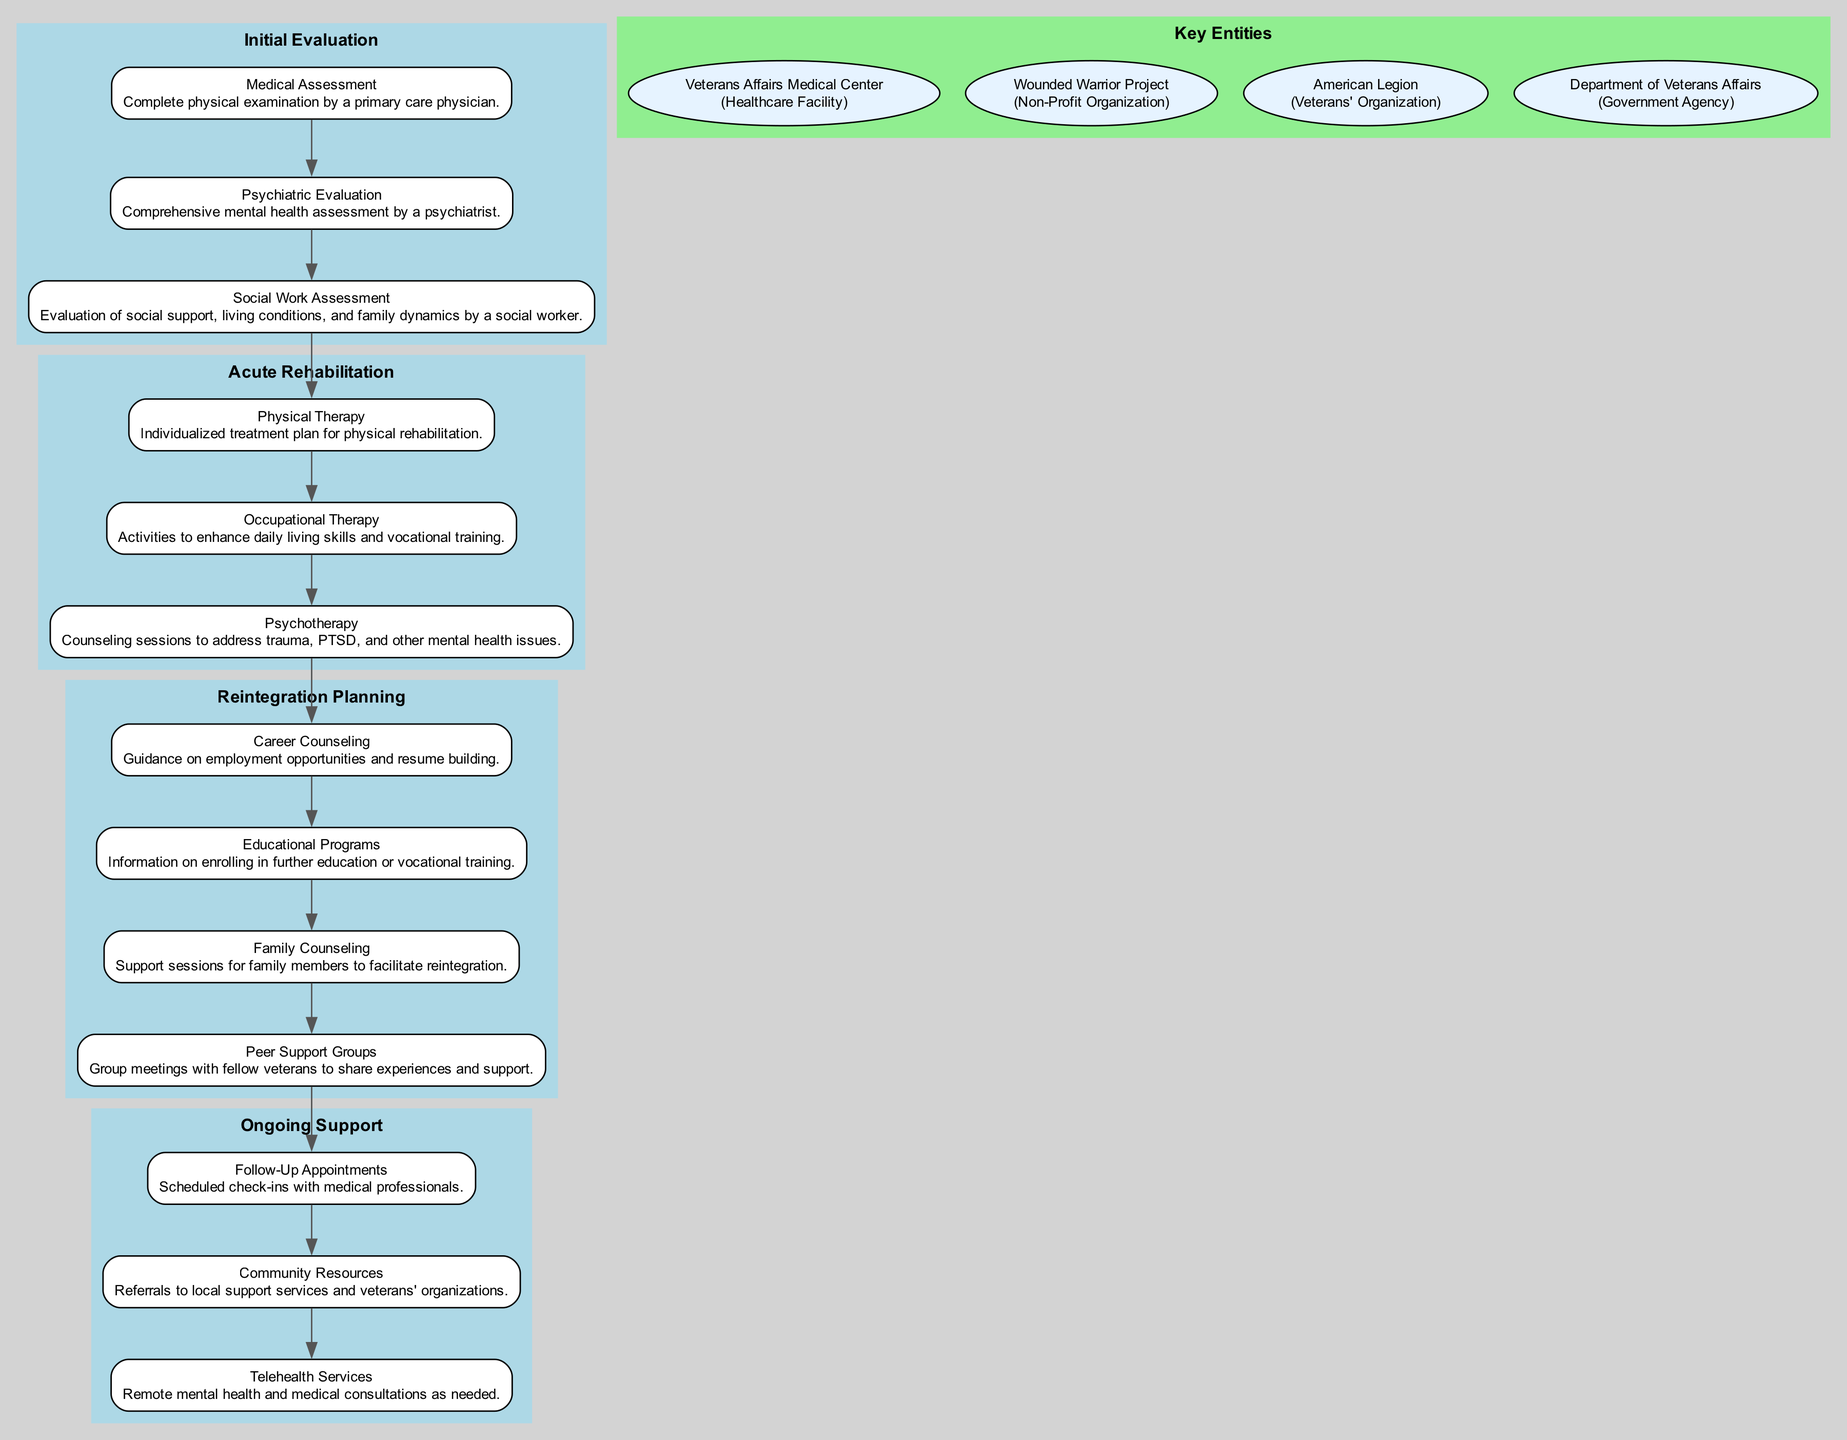What is the first step in the Initial Evaluation phase? The first step listed in the Initial Evaluation phase is the "Medical Assessment," which involves a complete physical examination.
Answer: Medical Assessment How many steps are there in the Acute Rehabilitation phase? The Acute Rehabilitation phase contains three steps: Physical Therapy, Occupational Therapy, and Psychotherapy.
Answer: 3 What type of organization is the Wounded Warrior Project? The Wounded Warrior Project is classified as a Non-Profit Organization.
Answer: Non-Profit Organization Which phase has the most steps? The Reintegration Planning phase has four steps: Career Counseling, Educational Programs, Family Counseling, and Peer Support Groups.
Answer: Reintegration Planning What connects the Acute Rehabilitation phase to the Reintegration Planning phase? The connection between these two phases is the last step of the Acute Rehabilitation phase leading to the first step of the Reintegration Planning phase.
Answer: Last step to First step What is one of the activities included in Occupational Therapy? Occupational Therapy includes activities aimed at enhancing daily living skills and vocational training for veterans.
Answer: Enhancing daily living skills How many key entities are listed in the diagram? There are four key entities noted in the diagram, including various organizations that support veterans.
Answer: 4 What type of support is provided in the Ongoing Support phase? The Ongoing Support phase provides various forms of support including Follow-Up Appointments, Community Resources, and Telehealth Services.
Answer: Follow-Up Appointments How many steps are involved in the Initial Evaluation phase? The Initial Evaluation phase consists of three steps: Medical Assessment, Psychiatric Evaluation, and Social Work Assessment.
Answer: 3 What is the last step in the Ongoing Support phase? The last step in the Ongoing Support phase is "Telehealth Services," which refers to remote consultations available for veterans.
Answer: Telehealth Services 